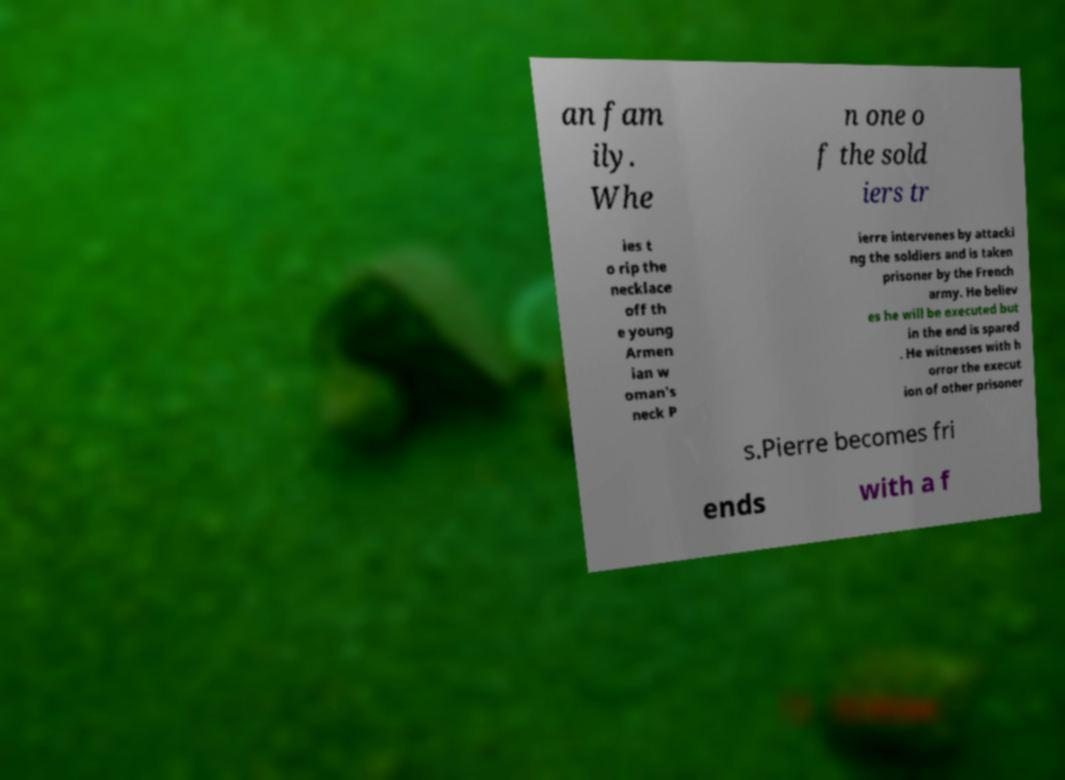Could you extract and type out the text from this image? an fam ily. Whe n one o f the sold iers tr ies t o rip the necklace off th e young Armen ian w oman's neck P ierre intervenes by attacki ng the soldiers and is taken prisoner by the French army. He believ es he will be executed but in the end is spared . He witnesses with h orror the execut ion of other prisoner s.Pierre becomes fri ends with a f 